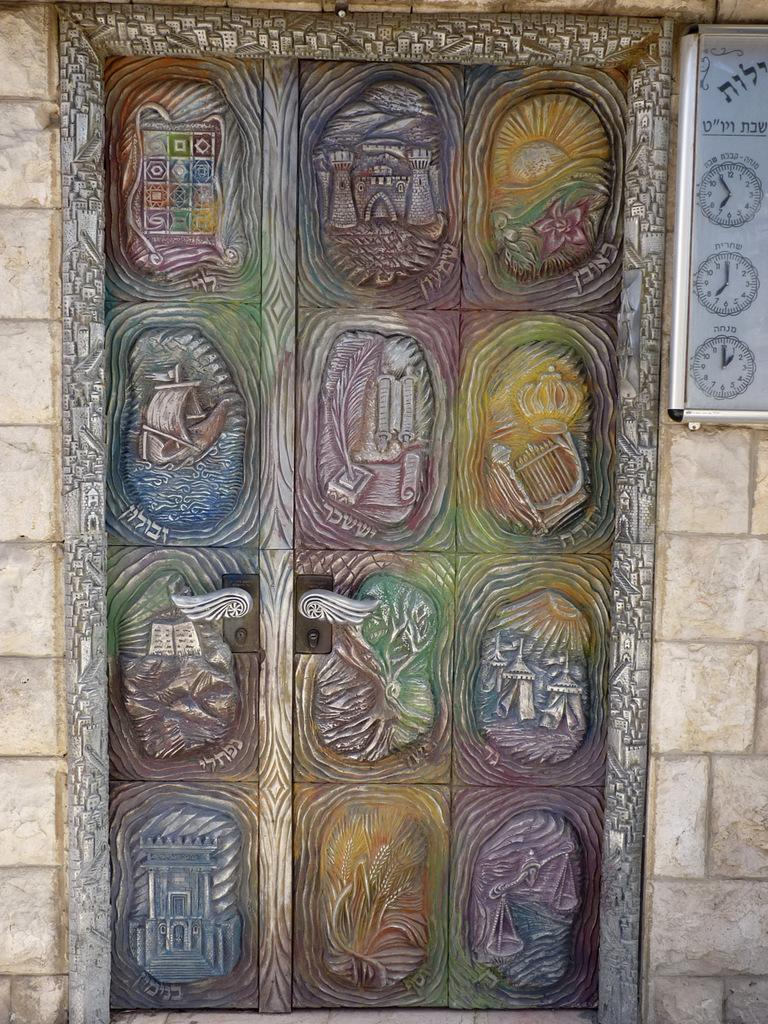What is the main subject of the image? The main subject of the image is a door. What feature does the door have? The door has a handle. How is the door visually distinct? The door has different sections and designs. What other object can be seen in the image? There is a clock board visible in the image. What type of oatmeal is being served in the image? There is no oatmeal present in the image; it features a close view of a door with a handle and different sections and designs, along with a visible clock board. 